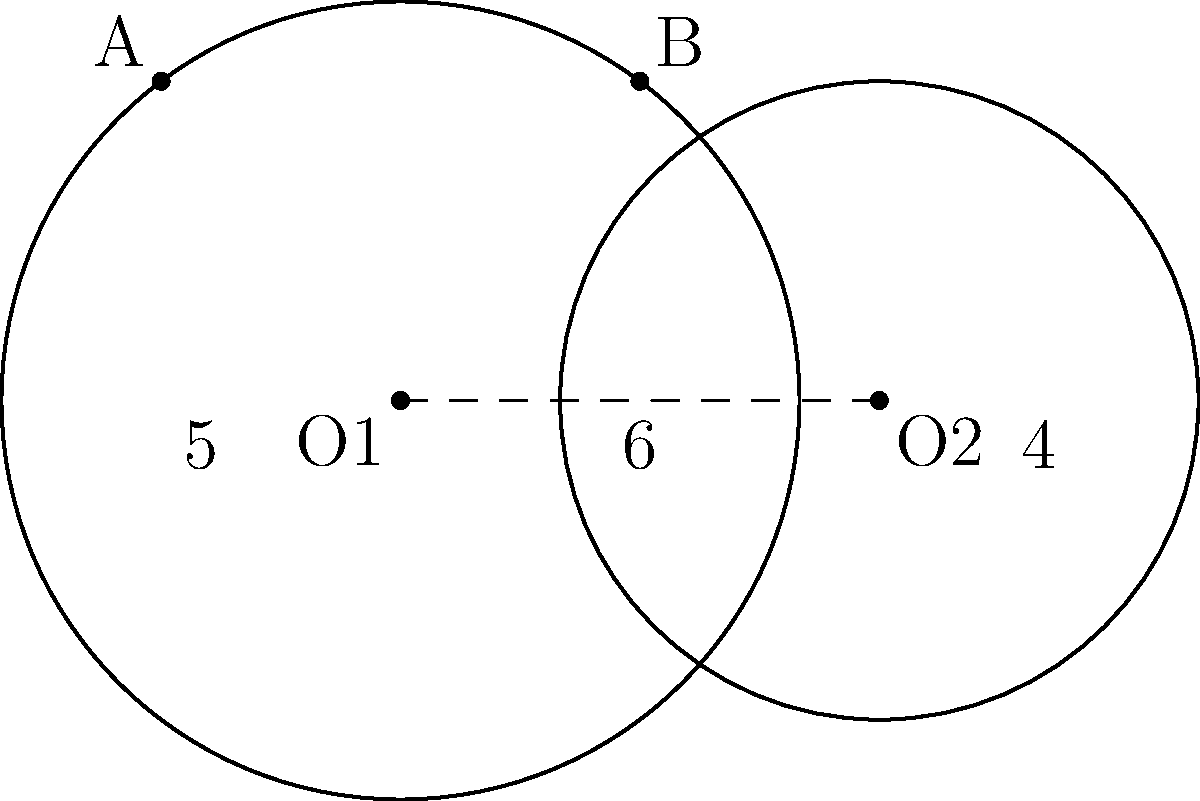Two kiteboarders are flying in circular paths centered at O1 and O2, respectively. The radius of the first kiteboarder's path is 5 units, and the second kiteboarder's path has a radius of 4 units. The centers of their paths are 6 units apart. Calculate the distance between the two intersection points of their flight paths, A and B. Let's approach this step-by-step:

1) First, we need to find the height of the triangle formed by O1, O2, and either intersection point (A or B). Let's call this height h.

2) We can use the Pythagorean theorem to set up two equations:

   For the first circle: $$(5^2 = x^2 + h^2)$$
   For the second circle: $$(4^2 = (6-x)^2 + h^2)$$

3) Expanding the second equation:
   $$16 = 36 - 12x + x^2 + h^2$$

4) From the first equation, we can express $h^2$:
   $$h^2 = 25 - x^2$$

5) Substituting this into the expanded second equation:
   $$16 = 36 - 12x + x^2 + (25 - x^2)$$
   $$16 = 61 - 12x$$
   $$12x = 45$$
   $$x = \frac{45}{12} = \frac{15}{4} = 3.75$$

6) Now we can find h by substituting x back into the equation from step 4:
   $$h^2 = 25 - (\frac{15}{4})^2 = 25 - \frac{225}{16} = \frac{400 - 225}{16} = \frac{175}{16}$$
   $$h = \frac{\sqrt{175}}{4} \approx 3.307$$

7) The distance between A and B is twice this height:
   $$AB = 2h = \frac{\sqrt{175}}{2} \approx 6.614$$

Therefore, the distance between the two intersection points is $\frac{\sqrt{175}}{2}$ units.
Answer: $\frac{\sqrt{175}}{2}$ units 